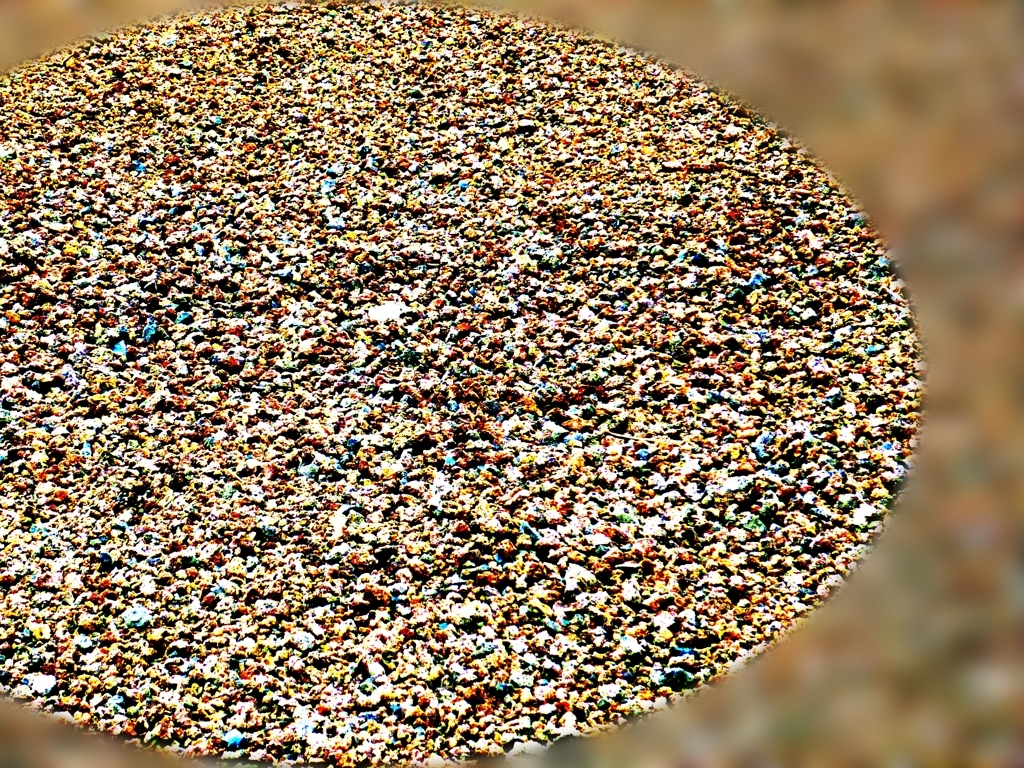Could you guess what time of day or specific conditions under which this photo was taken? Given the bright and consistent lighting in the image, it suggests that the photo may have been taken under strong daylight conditions, possibly around midday when the sun is high, resulting in minimal shadows. However, the lack of visible context makes it difficult to determine more precise conditions. 